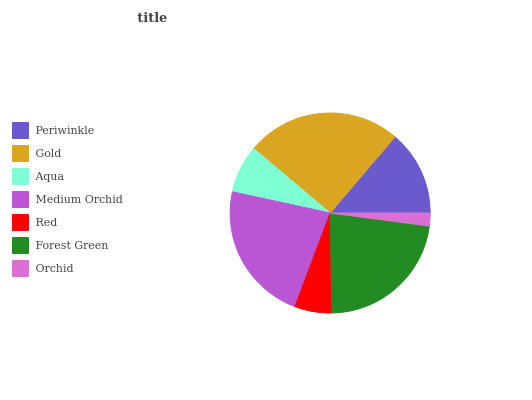Is Orchid the minimum?
Answer yes or no. Yes. Is Gold the maximum?
Answer yes or no. Yes. Is Aqua the minimum?
Answer yes or no. No. Is Aqua the maximum?
Answer yes or no. No. Is Gold greater than Aqua?
Answer yes or no. Yes. Is Aqua less than Gold?
Answer yes or no. Yes. Is Aqua greater than Gold?
Answer yes or no. No. Is Gold less than Aqua?
Answer yes or no. No. Is Periwinkle the high median?
Answer yes or no. Yes. Is Periwinkle the low median?
Answer yes or no. Yes. Is Orchid the high median?
Answer yes or no. No. Is Medium Orchid the low median?
Answer yes or no. No. 